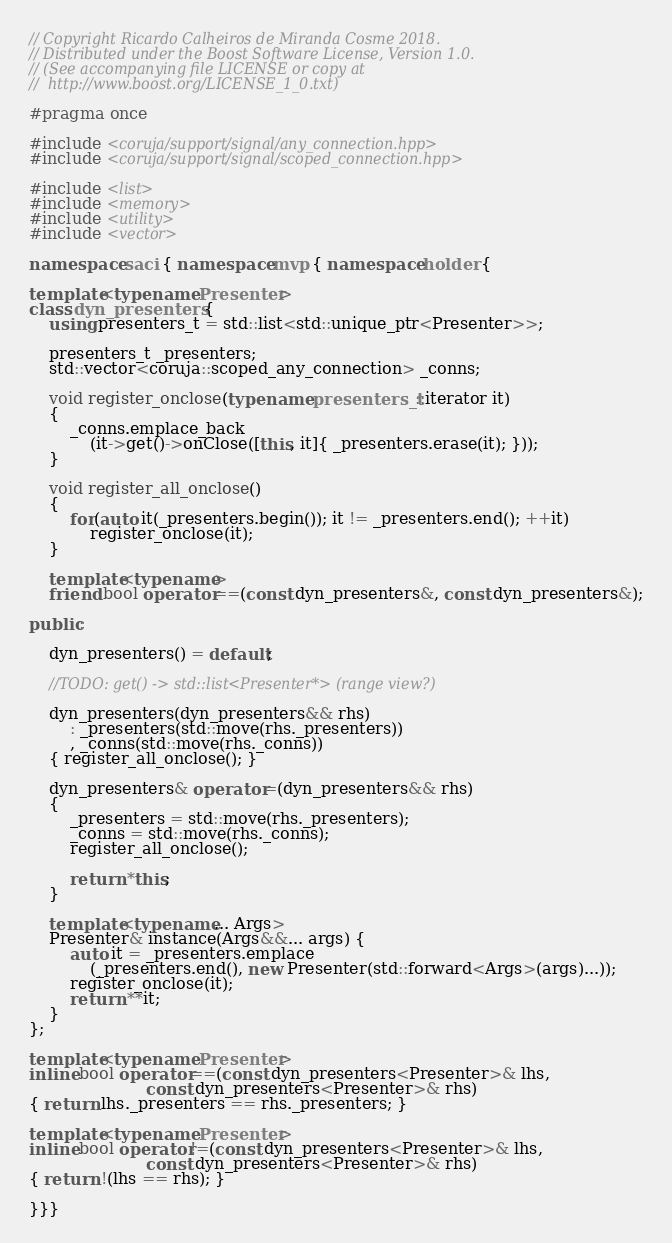<code> <loc_0><loc_0><loc_500><loc_500><_C++_>
// Copyright Ricardo Calheiros de Miranda Cosme 2018.
// Distributed under the Boost Software License, Version 1.0.
// (See accompanying file LICENSE or copy at
//  http://www.boost.org/LICENSE_1_0.txt)

#pragma once

#include <coruja/support/signal/any_connection.hpp>
#include <coruja/support/signal/scoped_connection.hpp>

#include <list>
#include <memory>
#include <utility>
#include <vector>

namespace saci { namespace mvp { namespace holder {

template<typename Presenter>
class dyn_presenters {
    using presenters_t = std::list<std::unique_ptr<Presenter>>;
    
    presenters_t _presenters;
    std::vector<coruja::scoped_any_connection> _conns;

    void register_onclose(typename presenters_t::iterator it)
    {
        _conns.emplace_back
            (it->get()->onClose([this, it]{ _presenters.erase(it); }));
    }

    void register_all_onclose()
    {
        for(auto it(_presenters.begin()); it != _presenters.end(); ++it)
            register_onclose(it);
    }
    
    template<typename>
    friend bool operator==(const dyn_presenters&, const dyn_presenters&);
    
public:
    
    dyn_presenters() = default;

    //TODO: get() -> std::list<Presenter*> (range view?)

    dyn_presenters(dyn_presenters&& rhs)
        : _presenters(std::move(rhs._presenters))
        , _conns(std::move(rhs._conns))
    { register_all_onclose(); }
    
    dyn_presenters& operator=(dyn_presenters&& rhs)
    {
        _presenters = std::move(rhs._presenters);
        _conns = std::move(rhs._conns);
        register_all_onclose();
        
        return *this;
    }
    
    template<typename... Args>
    Presenter& instance(Args&&... args) {
        auto it = _presenters.emplace
            (_presenters.end(), new Presenter(std::forward<Args>(args)...));
        register_onclose(it);
        return **it;
    }
};

template<typename Presenter>
inline bool operator==(const dyn_presenters<Presenter>& lhs,
                       const dyn_presenters<Presenter>& rhs)
{ return lhs._presenters == rhs._presenters; }

template<typename Presenter>
inline bool operator!=(const dyn_presenters<Presenter>& lhs,
                       const dyn_presenters<Presenter>& rhs)
{ return !(lhs == rhs); }

}}}
</code> 